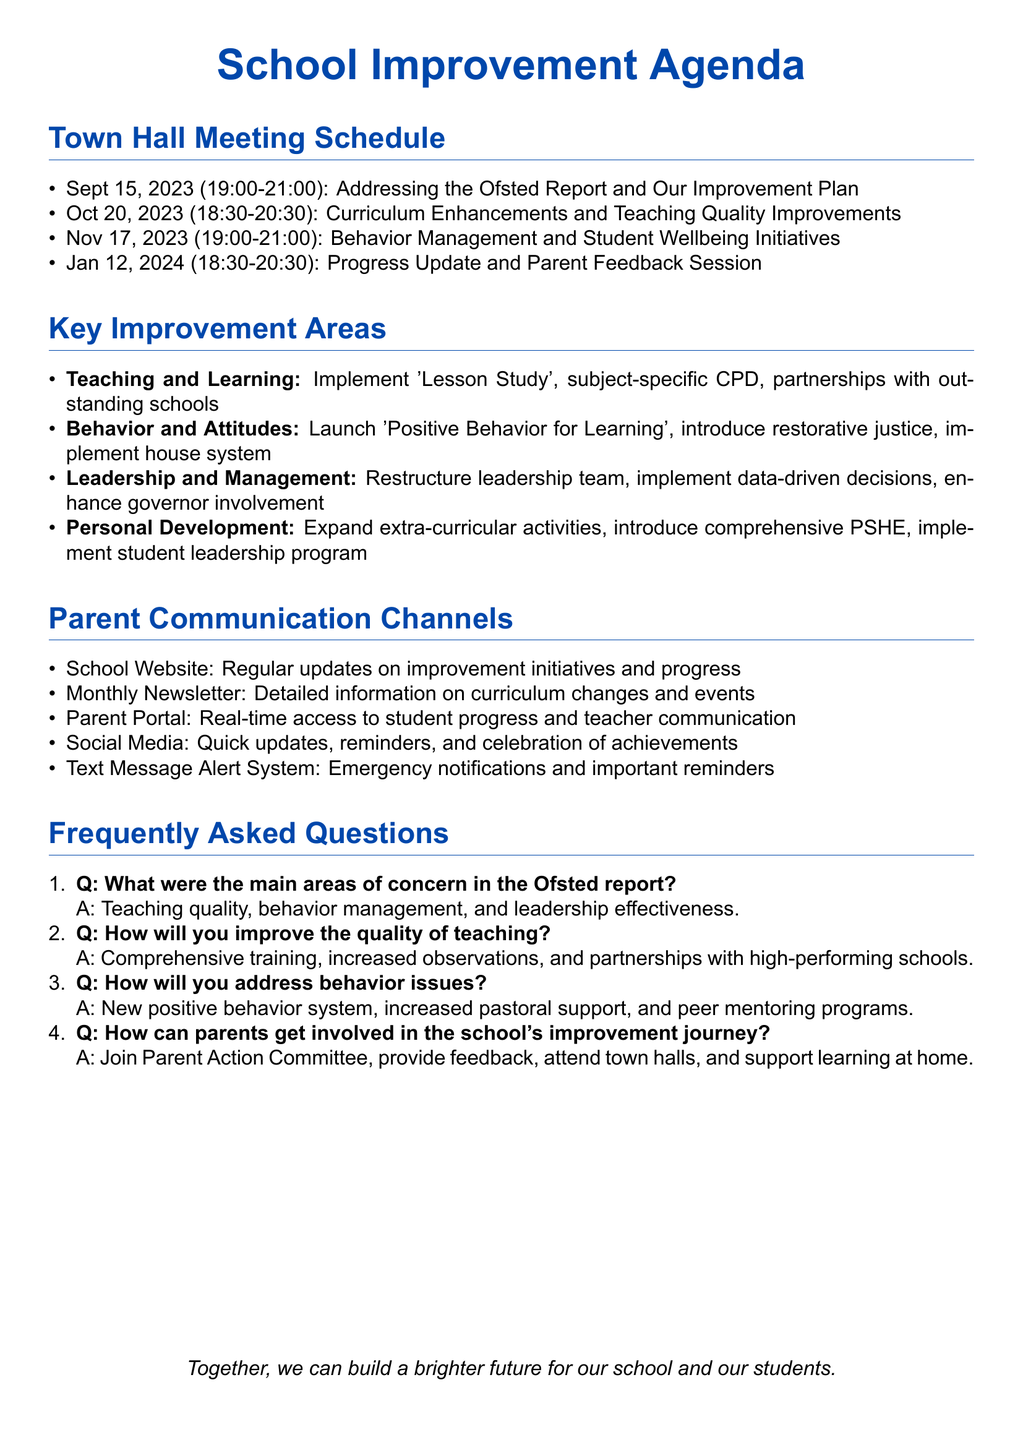What is the date of the first town hall meeting? The first town hall meeting is scheduled for September 15, 2023.
Answer: September 15, 2023 What is the location for the second town hall meeting? The second town hall meeting is to be held in the School Library.
Answer: School Library What is one of the main areas of concern mentioned in the Ofsted report? The document lists teaching quality in core subjects as a main area of concern.
Answer: Teaching quality in core subjects What initiative is being launched to improve behavior? The school is launching the "Positive Behavior for Learning" initiative to address behavior issues.
Answer: Positive Behavior for Learning How can parents get involved in the school's improvement journey? Parents can join the newly formed Parent Action Committee to engage in the school's improvement journey.
Answer: Parent Action Committee How many town hall meetings are scheduled between September 2023 and January 2024? There are four town hall meetings scheduled within this period.
Answer: Four What is the purpose of the Parent Portal? The Parent Portal provides real-time access to student progress and behavior reports.
Answer: Real-time access to student progress What action will be taken for leadership improvement? The school plans to restructure the senior leadership team with clear roles and accountabilities.
Answer: Restructure senior leadership team 